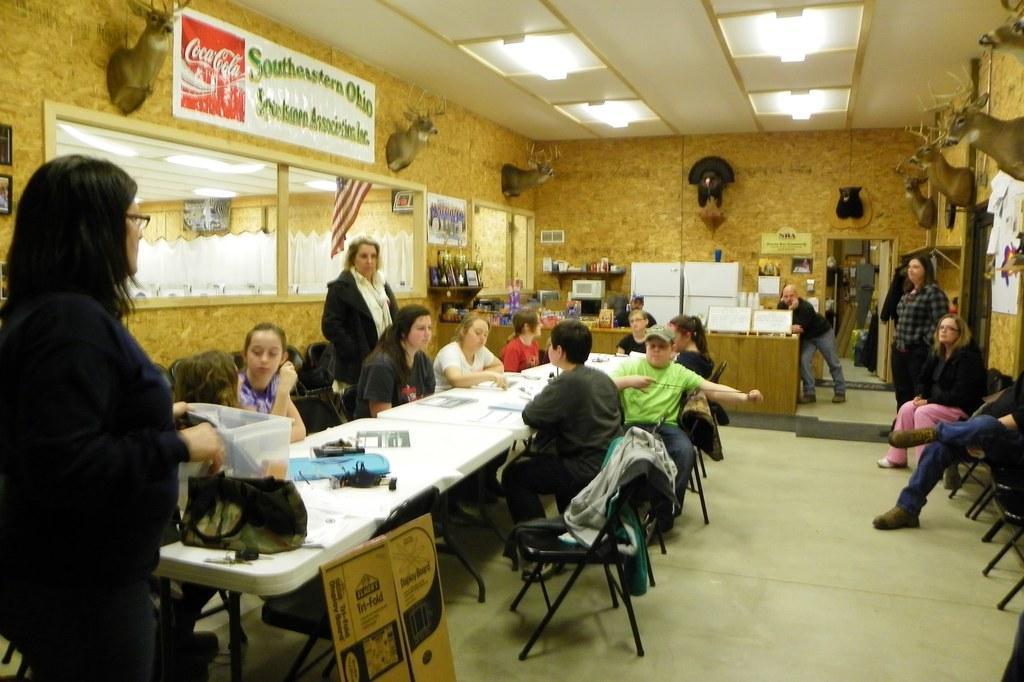Describe this image in one or two sentences. In the image we can see there are people who are sitting on the chairs and few people are standing. 